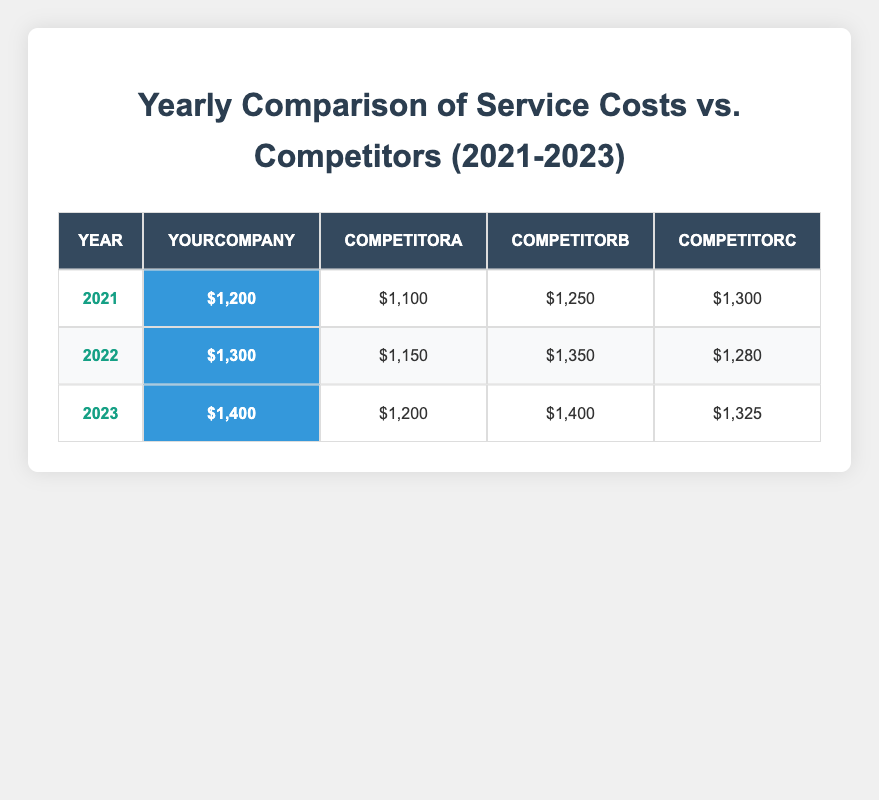What was the service cost for YourCompany in 2021? The table shows that in 2021, the service cost for YourCompany is highlighted as $1,200.
Answer: $1,200 Which competitor had the highest service cost in 2022? Looking at the service costs in 2022, CompetitorB has the highest cost at $1,350, while CompetitorA and CompetitorC have lower costs.
Answer: CompetitorB How much more did YourCompany charge compared to CompetitorA in 2023? In 2023, YourCompany's cost is $1,400 and CompetitorA's cost is $1,200. Calculating the difference: $1,400 - $1,200 = $200.
Answer: $200 What is the average service cost of YourCompany from 2021 to 2023? Adding up the service costs: $1,200 + $1,300 + $1,400 = $3,900. There are 3 years, so the average is $3,900 / 3 = $1,300.
Answer: $1,300 Did YourCompany’s service cost increase every year from 2021 to 2023? The table shows that the service costs increased from $1,200 in 2021 to $1,400 in 2023, confirming an increase each year.
Answer: Yes Which competitor had a service cost lower than YourCompany in 2021? CompetitorA at $1,100 had a lower cost compared to YourCompany, which was $1,200.
Answer: CompetitorA If we compare the total costs of YourCompany and all competitors for 2022, who had the lower total? Calculating the total costs: YourCompany = $1,300, CompetitorA = $1,150, CompetitorB = $1,350, CompetitorC = $1,280. The sum of competitors = $1,150 + $1,350 + $1,280 = $3,780. YourCompany = $1,300, so $3,780 > $1,300.
Answer: YourCompany Which year had the closest service cost between YourCompany and its competitors? Comparing the differences in service costs for each year: 2021 ($1,200 vs. $1,100) = $100, 2022 ($1,300 vs. $1,150) = $150, and 2023 ($1,400 vs. $1,200) = $200. The smallest difference is in 2021.
Answer: 2021 What was the total service cost for YourCompany over the three years? Adding the costs: $1,200 + $1,300 + $1,400 = $3,900.
Answer: $3,900 Did CompetitorC's service costs decrease from 2021 to 2023? Comparing the years: 2021 = $1,300, 2022 = $1,280, 2023 = $1,325. The cost actually increased from 2022 to 2023.
Answer: No 